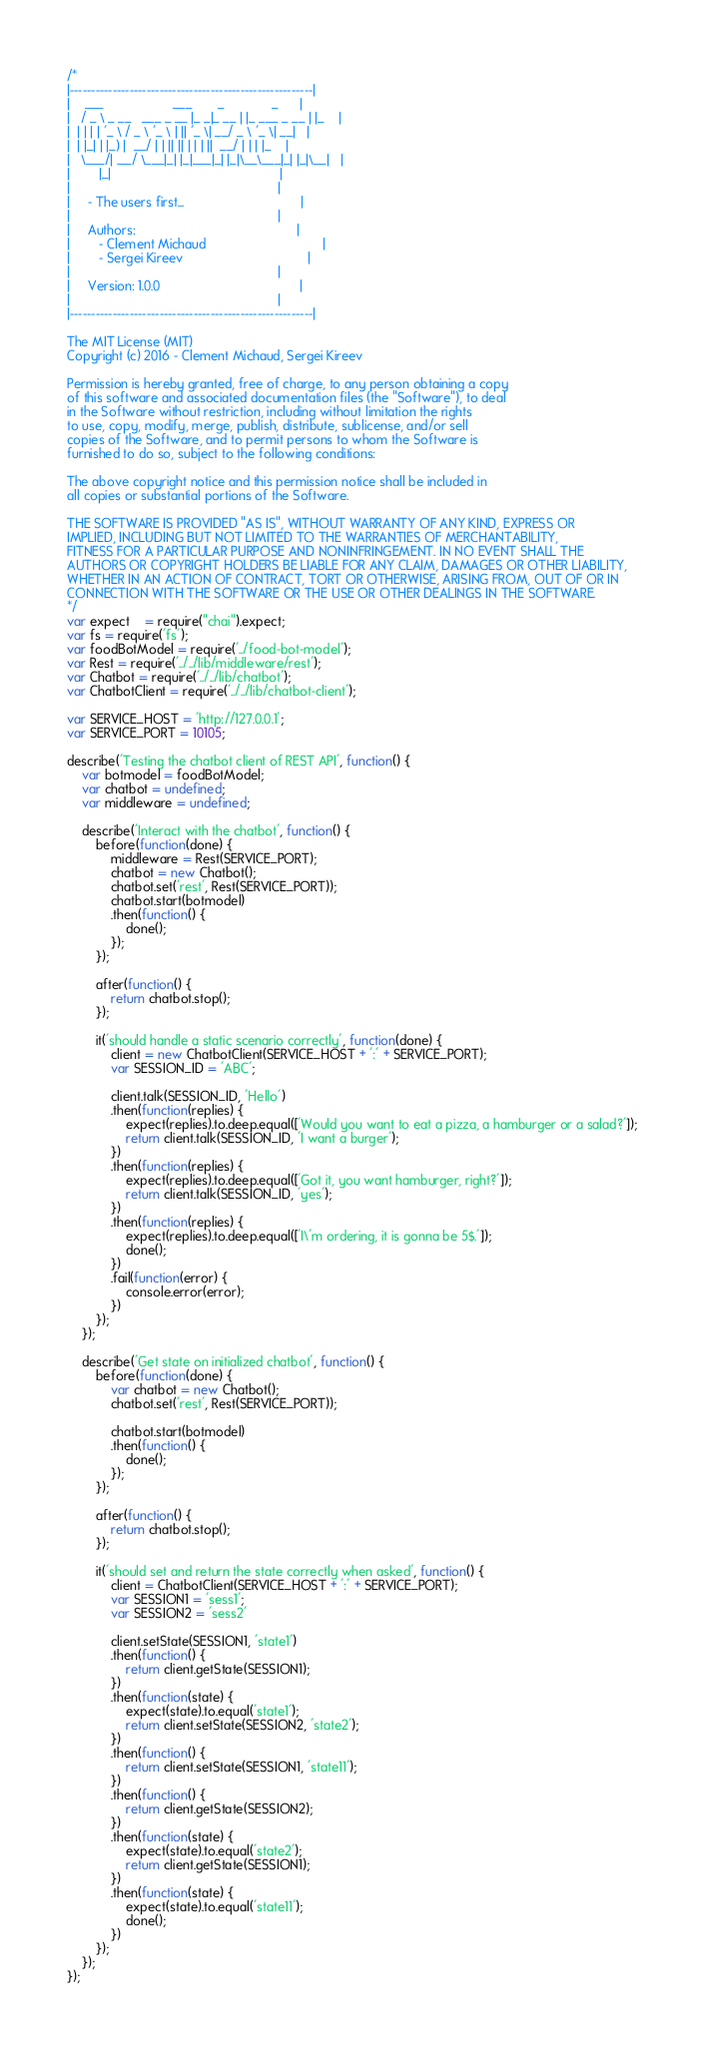<code> <loc_0><loc_0><loc_500><loc_500><_JavaScript_>/*
|---------------------------------------------------------|
|    ___                   ___       _             _      |
|   / _ \ _ __   ___ _ __ |_ _|_ __ | |_ ___ _ __ | |_    |
|  | | | | '_ \ / _ \ '_ \ | || '_ \| __/ _ \ '_ \| __|   |
|  | |_| | |_) |  __/ | | || || | | | ||  __/ | | | |_    |
|   \___/| .__/ \___|_| |_|___|_| |_|\__\___|_| |_|\__|   |
|        |_|                                              |
|                                                         |
|     - The users first...                                |
|                                                         |
|     Authors:                                            |
|        - Clement Michaud                                |
|        - Sergei Kireev                                  |
|                                                         |
|     Version: 1.0.0                                      |
|                                                         |
|---------------------------------------------------------|

The MIT License (MIT)
Copyright (c) 2016 - Clement Michaud, Sergei Kireev

Permission is hereby granted, free of charge, to any person obtaining a copy
of this software and associated documentation files (the "Software"), to deal
in the Software without restriction, including without limitation the rights
to use, copy, modify, merge, publish, distribute, sublicense, and/or sell
copies of the Software, and to permit persons to whom the Software is
furnished to do so, subject to the following conditions:

The above copyright notice and this permission notice shall be included in
all copies or substantial portions of the Software.

THE SOFTWARE IS PROVIDED "AS IS", WITHOUT WARRANTY OF ANY KIND, EXPRESS OR
IMPLIED, INCLUDING BUT NOT LIMITED TO THE WARRANTIES OF MERCHANTABILITY,
FITNESS FOR A PARTICULAR PURPOSE AND NONINFRINGEMENT. IN NO EVENT SHALL THE
AUTHORS OR COPYRIGHT HOLDERS BE LIABLE FOR ANY CLAIM, DAMAGES OR OTHER LIABILITY,
WHETHER IN AN ACTION OF CONTRACT, TORT OR OTHERWISE, ARISING FROM, OUT OF OR IN
CONNECTION WITH THE SOFTWARE OR THE USE OR OTHER DEALINGS IN THE SOFTWARE.
*/
var expect    = require("chai").expect;
var fs = require('fs');
var foodBotModel = require('../food-bot-model');
var Rest = require('../../lib/middleware/rest');
var Chatbot = require('../../lib/chatbot');
var ChatbotClient = require('../../lib/chatbot-client');

var SERVICE_HOST = 'http://127.0.0.1';
var SERVICE_PORT = 10105;

describe('Testing the chatbot client of REST API', function() {
    var botmodel = foodBotModel;
    var chatbot = undefined;
    var middleware = undefined;

    describe('Interact with the chatbot', function() {
        before(function(done) {
            middleware = Rest(SERVICE_PORT);
            chatbot = new Chatbot();
            chatbot.set('rest', Rest(SERVICE_PORT));
            chatbot.start(botmodel)
            .then(function() {
                done();
            });
        });

        after(function() {
            return chatbot.stop();
        });

        it('should handle a static scenario correctly', function(done) {
            client = new ChatbotClient(SERVICE_HOST + ':' + SERVICE_PORT);
            var SESSION_ID = 'ABC';

            client.talk(SESSION_ID, 'Hello')
            .then(function(replies) {
                expect(replies).to.deep.equal(['Would you want to eat a pizza, a hamburger or a salad?']);
                return client.talk(SESSION_ID, 'I want a burger');
            })
            .then(function(replies) {
                expect(replies).to.deep.equal(['Got it, you want hamburger, right?']);
                return client.talk(SESSION_ID, 'yes');
            })
            .then(function(replies) {
                expect(replies).to.deep.equal(['I\'m ordering, it is gonna be 5$.']);
                done();
            })
            .fail(function(error) {
                console.error(error);
            })
        });
    });

    describe('Get state on initialized chatbot', function() {
        before(function(done) {
            var chatbot = new Chatbot();
            chatbot.set('rest', Rest(SERVICE_PORT));

            chatbot.start(botmodel)
            .then(function() {
                done();
            });
        });

        after(function() {
            return chatbot.stop();
        });

        it('should set and return the state correctly when asked', function() {
            client = ChatbotClient(SERVICE_HOST + ':' + SERVICE_PORT);
            var SESSION1 = 'sess1';
            var SESSION2 = 'sess2'

            client.setState(SESSION1, 'state1')
            .then(function() {
                return client.getState(SESSION1);
            })
            .then(function(state) {
                expect(state).to.equal('state1');
                return client.setState(SESSION2, 'state2');
            })
            .then(function() {
                return client.setState(SESSION1, 'state11');
            })
            .then(function() {
                return client.getState(SESSION2);
            })
            .then(function(state) {
                expect(state).to.equal('state2');
                return client.getState(SESSION1);
            })
            .then(function(state) {
                expect(state).to.equal('state11');
                done();
            })
        });
    });
});
</code> 